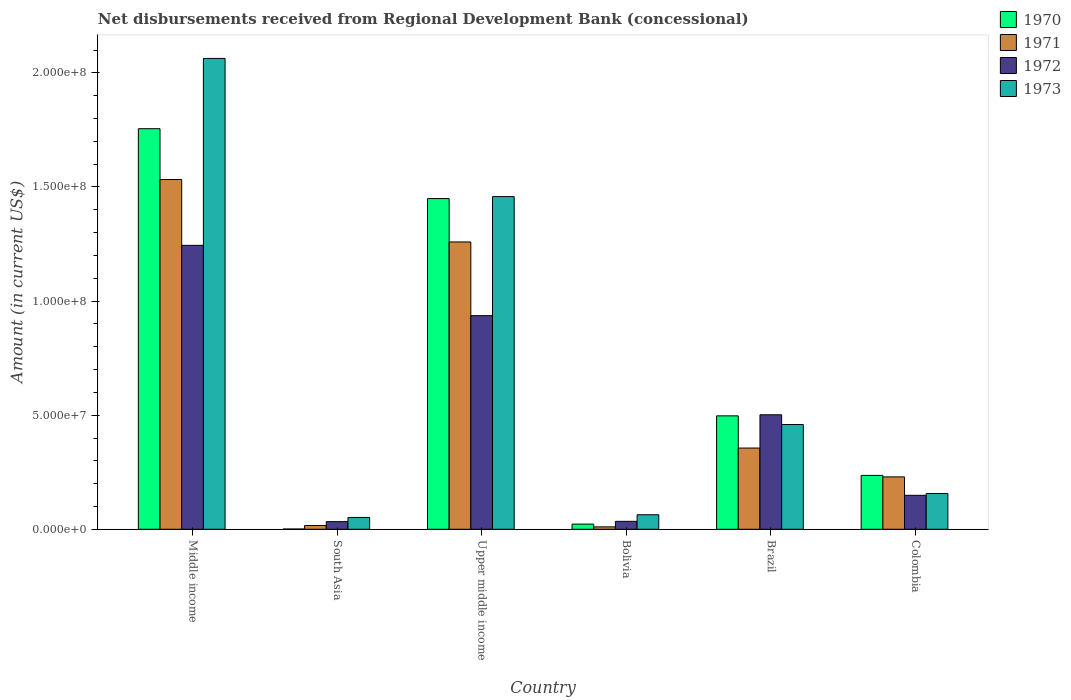How many different coloured bars are there?
Your response must be concise. 4. How many groups of bars are there?
Your response must be concise. 6. What is the label of the 2nd group of bars from the left?
Offer a terse response. South Asia. In how many cases, is the number of bars for a given country not equal to the number of legend labels?
Give a very brief answer. 0. What is the amount of disbursements received from Regional Development Bank in 1971 in Middle income?
Provide a succinct answer. 1.53e+08. Across all countries, what is the maximum amount of disbursements received from Regional Development Bank in 1971?
Offer a terse response. 1.53e+08. Across all countries, what is the minimum amount of disbursements received from Regional Development Bank in 1973?
Provide a short and direct response. 5.18e+06. In which country was the amount of disbursements received from Regional Development Bank in 1973 maximum?
Make the answer very short. Middle income. In which country was the amount of disbursements received from Regional Development Bank in 1972 minimum?
Offer a very short reply. South Asia. What is the total amount of disbursements received from Regional Development Bank in 1971 in the graph?
Your answer should be very brief. 3.40e+08. What is the difference between the amount of disbursements received from Regional Development Bank in 1970 in Bolivia and that in Colombia?
Provide a short and direct response. -2.13e+07. What is the difference between the amount of disbursements received from Regional Development Bank in 1971 in Upper middle income and the amount of disbursements received from Regional Development Bank in 1972 in Brazil?
Keep it short and to the point. 7.57e+07. What is the average amount of disbursements received from Regional Development Bank in 1972 per country?
Keep it short and to the point. 4.83e+07. What is the difference between the amount of disbursements received from Regional Development Bank of/in 1972 and amount of disbursements received from Regional Development Bank of/in 1970 in Upper middle income?
Ensure brevity in your answer.  -5.13e+07. What is the ratio of the amount of disbursements received from Regional Development Bank in 1971 in Bolivia to that in Upper middle income?
Give a very brief answer. 0.01. Is the difference between the amount of disbursements received from Regional Development Bank in 1972 in Bolivia and Middle income greater than the difference between the amount of disbursements received from Regional Development Bank in 1970 in Bolivia and Middle income?
Your answer should be compact. Yes. What is the difference between the highest and the second highest amount of disbursements received from Regional Development Bank in 1973?
Your answer should be very brief. 1.60e+08. What is the difference between the highest and the lowest amount of disbursements received from Regional Development Bank in 1973?
Provide a succinct answer. 2.01e+08. In how many countries, is the amount of disbursements received from Regional Development Bank in 1972 greater than the average amount of disbursements received from Regional Development Bank in 1972 taken over all countries?
Provide a succinct answer. 3. Is the sum of the amount of disbursements received from Regional Development Bank in 1971 in Bolivia and South Asia greater than the maximum amount of disbursements received from Regional Development Bank in 1972 across all countries?
Your response must be concise. No. Is it the case that in every country, the sum of the amount of disbursements received from Regional Development Bank in 1972 and amount of disbursements received from Regional Development Bank in 1970 is greater than the sum of amount of disbursements received from Regional Development Bank in 1973 and amount of disbursements received from Regional Development Bank in 1971?
Your answer should be very brief. No. Is it the case that in every country, the sum of the amount of disbursements received from Regional Development Bank in 1971 and amount of disbursements received from Regional Development Bank in 1972 is greater than the amount of disbursements received from Regional Development Bank in 1973?
Make the answer very short. No. Does the graph contain any zero values?
Keep it short and to the point. No. Where does the legend appear in the graph?
Keep it short and to the point. Top right. How many legend labels are there?
Give a very brief answer. 4. What is the title of the graph?
Offer a very short reply. Net disbursements received from Regional Development Bank (concessional). What is the Amount (in current US$) in 1970 in Middle income?
Make the answer very short. 1.76e+08. What is the Amount (in current US$) in 1971 in Middle income?
Your answer should be compact. 1.53e+08. What is the Amount (in current US$) in 1972 in Middle income?
Give a very brief answer. 1.24e+08. What is the Amount (in current US$) of 1973 in Middle income?
Your answer should be very brief. 2.06e+08. What is the Amount (in current US$) in 1970 in South Asia?
Keep it short and to the point. 1.09e+05. What is the Amount (in current US$) of 1971 in South Asia?
Offer a terse response. 1.65e+06. What is the Amount (in current US$) in 1972 in South Asia?
Make the answer very short. 3.35e+06. What is the Amount (in current US$) in 1973 in South Asia?
Your answer should be compact. 5.18e+06. What is the Amount (in current US$) of 1970 in Upper middle income?
Your answer should be compact. 1.45e+08. What is the Amount (in current US$) in 1971 in Upper middle income?
Offer a very short reply. 1.26e+08. What is the Amount (in current US$) of 1972 in Upper middle income?
Your answer should be compact. 9.36e+07. What is the Amount (in current US$) of 1973 in Upper middle income?
Ensure brevity in your answer.  1.46e+08. What is the Amount (in current US$) in 1970 in Bolivia?
Keep it short and to the point. 2.27e+06. What is the Amount (in current US$) of 1971 in Bolivia?
Your response must be concise. 1.06e+06. What is the Amount (in current US$) of 1972 in Bolivia?
Offer a terse response. 3.48e+06. What is the Amount (in current US$) in 1973 in Bolivia?
Your response must be concise. 6.36e+06. What is the Amount (in current US$) of 1970 in Brazil?
Make the answer very short. 4.97e+07. What is the Amount (in current US$) of 1971 in Brazil?
Provide a succinct answer. 3.56e+07. What is the Amount (in current US$) of 1972 in Brazil?
Ensure brevity in your answer.  5.02e+07. What is the Amount (in current US$) in 1973 in Brazil?
Provide a succinct answer. 4.59e+07. What is the Amount (in current US$) in 1970 in Colombia?
Your answer should be compact. 2.36e+07. What is the Amount (in current US$) in 1971 in Colombia?
Your answer should be very brief. 2.30e+07. What is the Amount (in current US$) in 1972 in Colombia?
Provide a short and direct response. 1.49e+07. What is the Amount (in current US$) in 1973 in Colombia?
Provide a succinct answer. 1.57e+07. Across all countries, what is the maximum Amount (in current US$) of 1970?
Provide a short and direct response. 1.76e+08. Across all countries, what is the maximum Amount (in current US$) of 1971?
Your answer should be compact. 1.53e+08. Across all countries, what is the maximum Amount (in current US$) in 1972?
Your answer should be very brief. 1.24e+08. Across all countries, what is the maximum Amount (in current US$) of 1973?
Provide a short and direct response. 2.06e+08. Across all countries, what is the minimum Amount (in current US$) of 1970?
Provide a short and direct response. 1.09e+05. Across all countries, what is the minimum Amount (in current US$) in 1971?
Ensure brevity in your answer.  1.06e+06. Across all countries, what is the minimum Amount (in current US$) in 1972?
Keep it short and to the point. 3.35e+06. Across all countries, what is the minimum Amount (in current US$) of 1973?
Offer a terse response. 5.18e+06. What is the total Amount (in current US$) of 1970 in the graph?
Keep it short and to the point. 3.96e+08. What is the total Amount (in current US$) in 1971 in the graph?
Offer a terse response. 3.40e+08. What is the total Amount (in current US$) of 1972 in the graph?
Offer a very short reply. 2.90e+08. What is the total Amount (in current US$) in 1973 in the graph?
Your response must be concise. 4.25e+08. What is the difference between the Amount (in current US$) in 1970 in Middle income and that in South Asia?
Your answer should be compact. 1.75e+08. What is the difference between the Amount (in current US$) in 1971 in Middle income and that in South Asia?
Offer a very short reply. 1.52e+08. What is the difference between the Amount (in current US$) of 1972 in Middle income and that in South Asia?
Keep it short and to the point. 1.21e+08. What is the difference between the Amount (in current US$) in 1973 in Middle income and that in South Asia?
Offer a terse response. 2.01e+08. What is the difference between the Amount (in current US$) in 1970 in Middle income and that in Upper middle income?
Provide a short and direct response. 3.06e+07. What is the difference between the Amount (in current US$) of 1971 in Middle income and that in Upper middle income?
Your response must be concise. 2.74e+07. What is the difference between the Amount (in current US$) in 1972 in Middle income and that in Upper middle income?
Keep it short and to the point. 3.08e+07. What is the difference between the Amount (in current US$) of 1973 in Middle income and that in Upper middle income?
Provide a short and direct response. 6.06e+07. What is the difference between the Amount (in current US$) of 1970 in Middle income and that in Bolivia?
Offer a terse response. 1.73e+08. What is the difference between the Amount (in current US$) in 1971 in Middle income and that in Bolivia?
Provide a succinct answer. 1.52e+08. What is the difference between the Amount (in current US$) of 1972 in Middle income and that in Bolivia?
Make the answer very short. 1.21e+08. What is the difference between the Amount (in current US$) of 1973 in Middle income and that in Bolivia?
Your response must be concise. 2.00e+08. What is the difference between the Amount (in current US$) in 1970 in Middle income and that in Brazil?
Provide a succinct answer. 1.26e+08. What is the difference between the Amount (in current US$) in 1971 in Middle income and that in Brazil?
Your answer should be very brief. 1.18e+08. What is the difference between the Amount (in current US$) of 1972 in Middle income and that in Brazil?
Provide a short and direct response. 7.43e+07. What is the difference between the Amount (in current US$) in 1973 in Middle income and that in Brazil?
Your response must be concise. 1.60e+08. What is the difference between the Amount (in current US$) of 1970 in Middle income and that in Colombia?
Make the answer very short. 1.52e+08. What is the difference between the Amount (in current US$) in 1971 in Middle income and that in Colombia?
Offer a very short reply. 1.30e+08. What is the difference between the Amount (in current US$) of 1972 in Middle income and that in Colombia?
Your answer should be very brief. 1.10e+08. What is the difference between the Amount (in current US$) in 1973 in Middle income and that in Colombia?
Your answer should be compact. 1.91e+08. What is the difference between the Amount (in current US$) in 1970 in South Asia and that in Upper middle income?
Your response must be concise. -1.45e+08. What is the difference between the Amount (in current US$) in 1971 in South Asia and that in Upper middle income?
Keep it short and to the point. -1.24e+08. What is the difference between the Amount (in current US$) in 1972 in South Asia and that in Upper middle income?
Provide a succinct answer. -9.03e+07. What is the difference between the Amount (in current US$) of 1973 in South Asia and that in Upper middle income?
Give a very brief answer. -1.41e+08. What is the difference between the Amount (in current US$) in 1970 in South Asia and that in Bolivia?
Ensure brevity in your answer.  -2.16e+06. What is the difference between the Amount (in current US$) of 1971 in South Asia and that in Bolivia?
Ensure brevity in your answer.  5.92e+05. What is the difference between the Amount (in current US$) in 1972 in South Asia and that in Bolivia?
Provide a succinct answer. -1.30e+05. What is the difference between the Amount (in current US$) in 1973 in South Asia and that in Bolivia?
Keep it short and to the point. -1.18e+06. What is the difference between the Amount (in current US$) of 1970 in South Asia and that in Brazil?
Offer a very short reply. -4.96e+07. What is the difference between the Amount (in current US$) in 1971 in South Asia and that in Brazil?
Give a very brief answer. -3.39e+07. What is the difference between the Amount (in current US$) of 1972 in South Asia and that in Brazil?
Offer a terse response. -4.68e+07. What is the difference between the Amount (in current US$) in 1973 in South Asia and that in Brazil?
Keep it short and to the point. -4.07e+07. What is the difference between the Amount (in current US$) in 1970 in South Asia and that in Colombia?
Your answer should be compact. -2.35e+07. What is the difference between the Amount (in current US$) of 1971 in South Asia and that in Colombia?
Offer a very short reply. -2.13e+07. What is the difference between the Amount (in current US$) in 1972 in South Asia and that in Colombia?
Give a very brief answer. -1.15e+07. What is the difference between the Amount (in current US$) of 1973 in South Asia and that in Colombia?
Provide a succinct answer. -1.05e+07. What is the difference between the Amount (in current US$) in 1970 in Upper middle income and that in Bolivia?
Offer a terse response. 1.43e+08. What is the difference between the Amount (in current US$) of 1971 in Upper middle income and that in Bolivia?
Provide a short and direct response. 1.25e+08. What is the difference between the Amount (in current US$) in 1972 in Upper middle income and that in Bolivia?
Provide a short and direct response. 9.01e+07. What is the difference between the Amount (in current US$) in 1973 in Upper middle income and that in Bolivia?
Your answer should be very brief. 1.39e+08. What is the difference between the Amount (in current US$) in 1970 in Upper middle income and that in Brazil?
Provide a succinct answer. 9.52e+07. What is the difference between the Amount (in current US$) of 1971 in Upper middle income and that in Brazil?
Your answer should be very brief. 9.03e+07. What is the difference between the Amount (in current US$) in 1972 in Upper middle income and that in Brazil?
Ensure brevity in your answer.  4.34e+07. What is the difference between the Amount (in current US$) of 1973 in Upper middle income and that in Brazil?
Make the answer very short. 9.99e+07. What is the difference between the Amount (in current US$) of 1970 in Upper middle income and that in Colombia?
Your response must be concise. 1.21e+08. What is the difference between the Amount (in current US$) of 1971 in Upper middle income and that in Colombia?
Your answer should be very brief. 1.03e+08. What is the difference between the Amount (in current US$) of 1972 in Upper middle income and that in Colombia?
Your answer should be compact. 7.87e+07. What is the difference between the Amount (in current US$) of 1973 in Upper middle income and that in Colombia?
Make the answer very short. 1.30e+08. What is the difference between the Amount (in current US$) of 1970 in Bolivia and that in Brazil?
Offer a terse response. -4.74e+07. What is the difference between the Amount (in current US$) in 1971 in Bolivia and that in Brazil?
Your answer should be very brief. -3.45e+07. What is the difference between the Amount (in current US$) in 1972 in Bolivia and that in Brazil?
Your response must be concise. -4.67e+07. What is the difference between the Amount (in current US$) in 1973 in Bolivia and that in Brazil?
Your answer should be compact. -3.95e+07. What is the difference between the Amount (in current US$) in 1970 in Bolivia and that in Colombia?
Offer a very short reply. -2.13e+07. What is the difference between the Amount (in current US$) in 1971 in Bolivia and that in Colombia?
Provide a short and direct response. -2.19e+07. What is the difference between the Amount (in current US$) of 1972 in Bolivia and that in Colombia?
Make the answer very short. -1.14e+07. What is the difference between the Amount (in current US$) of 1973 in Bolivia and that in Colombia?
Give a very brief answer. -9.33e+06. What is the difference between the Amount (in current US$) in 1970 in Brazil and that in Colombia?
Make the answer very short. 2.61e+07. What is the difference between the Amount (in current US$) of 1971 in Brazil and that in Colombia?
Keep it short and to the point. 1.26e+07. What is the difference between the Amount (in current US$) of 1972 in Brazil and that in Colombia?
Your response must be concise. 3.53e+07. What is the difference between the Amount (in current US$) of 1973 in Brazil and that in Colombia?
Offer a terse response. 3.02e+07. What is the difference between the Amount (in current US$) of 1970 in Middle income and the Amount (in current US$) of 1971 in South Asia?
Provide a short and direct response. 1.74e+08. What is the difference between the Amount (in current US$) in 1970 in Middle income and the Amount (in current US$) in 1972 in South Asia?
Your answer should be compact. 1.72e+08. What is the difference between the Amount (in current US$) in 1970 in Middle income and the Amount (in current US$) in 1973 in South Asia?
Provide a short and direct response. 1.70e+08. What is the difference between the Amount (in current US$) in 1971 in Middle income and the Amount (in current US$) in 1972 in South Asia?
Provide a succinct answer. 1.50e+08. What is the difference between the Amount (in current US$) in 1971 in Middle income and the Amount (in current US$) in 1973 in South Asia?
Make the answer very short. 1.48e+08. What is the difference between the Amount (in current US$) of 1972 in Middle income and the Amount (in current US$) of 1973 in South Asia?
Provide a short and direct response. 1.19e+08. What is the difference between the Amount (in current US$) of 1970 in Middle income and the Amount (in current US$) of 1971 in Upper middle income?
Make the answer very short. 4.96e+07. What is the difference between the Amount (in current US$) in 1970 in Middle income and the Amount (in current US$) in 1972 in Upper middle income?
Offer a terse response. 8.19e+07. What is the difference between the Amount (in current US$) in 1970 in Middle income and the Amount (in current US$) in 1973 in Upper middle income?
Provide a succinct answer. 2.98e+07. What is the difference between the Amount (in current US$) in 1971 in Middle income and the Amount (in current US$) in 1972 in Upper middle income?
Your answer should be compact. 5.97e+07. What is the difference between the Amount (in current US$) of 1971 in Middle income and the Amount (in current US$) of 1973 in Upper middle income?
Your answer should be very brief. 7.49e+06. What is the difference between the Amount (in current US$) in 1972 in Middle income and the Amount (in current US$) in 1973 in Upper middle income?
Your response must be concise. -2.14e+07. What is the difference between the Amount (in current US$) of 1970 in Middle income and the Amount (in current US$) of 1971 in Bolivia?
Offer a very short reply. 1.74e+08. What is the difference between the Amount (in current US$) of 1970 in Middle income and the Amount (in current US$) of 1972 in Bolivia?
Your answer should be compact. 1.72e+08. What is the difference between the Amount (in current US$) in 1970 in Middle income and the Amount (in current US$) in 1973 in Bolivia?
Your response must be concise. 1.69e+08. What is the difference between the Amount (in current US$) of 1971 in Middle income and the Amount (in current US$) of 1972 in Bolivia?
Give a very brief answer. 1.50e+08. What is the difference between the Amount (in current US$) in 1971 in Middle income and the Amount (in current US$) in 1973 in Bolivia?
Offer a very short reply. 1.47e+08. What is the difference between the Amount (in current US$) in 1972 in Middle income and the Amount (in current US$) in 1973 in Bolivia?
Provide a succinct answer. 1.18e+08. What is the difference between the Amount (in current US$) of 1970 in Middle income and the Amount (in current US$) of 1971 in Brazil?
Your answer should be very brief. 1.40e+08. What is the difference between the Amount (in current US$) of 1970 in Middle income and the Amount (in current US$) of 1972 in Brazil?
Provide a succinct answer. 1.25e+08. What is the difference between the Amount (in current US$) of 1970 in Middle income and the Amount (in current US$) of 1973 in Brazil?
Your answer should be compact. 1.30e+08. What is the difference between the Amount (in current US$) in 1971 in Middle income and the Amount (in current US$) in 1972 in Brazil?
Provide a succinct answer. 1.03e+08. What is the difference between the Amount (in current US$) in 1971 in Middle income and the Amount (in current US$) in 1973 in Brazil?
Give a very brief answer. 1.07e+08. What is the difference between the Amount (in current US$) of 1972 in Middle income and the Amount (in current US$) of 1973 in Brazil?
Ensure brevity in your answer.  7.85e+07. What is the difference between the Amount (in current US$) in 1970 in Middle income and the Amount (in current US$) in 1971 in Colombia?
Your response must be concise. 1.53e+08. What is the difference between the Amount (in current US$) of 1970 in Middle income and the Amount (in current US$) of 1972 in Colombia?
Your response must be concise. 1.61e+08. What is the difference between the Amount (in current US$) of 1970 in Middle income and the Amount (in current US$) of 1973 in Colombia?
Offer a very short reply. 1.60e+08. What is the difference between the Amount (in current US$) in 1971 in Middle income and the Amount (in current US$) in 1972 in Colombia?
Provide a succinct answer. 1.38e+08. What is the difference between the Amount (in current US$) in 1971 in Middle income and the Amount (in current US$) in 1973 in Colombia?
Provide a short and direct response. 1.38e+08. What is the difference between the Amount (in current US$) of 1972 in Middle income and the Amount (in current US$) of 1973 in Colombia?
Provide a succinct answer. 1.09e+08. What is the difference between the Amount (in current US$) in 1970 in South Asia and the Amount (in current US$) in 1971 in Upper middle income?
Your response must be concise. -1.26e+08. What is the difference between the Amount (in current US$) of 1970 in South Asia and the Amount (in current US$) of 1972 in Upper middle income?
Ensure brevity in your answer.  -9.35e+07. What is the difference between the Amount (in current US$) in 1970 in South Asia and the Amount (in current US$) in 1973 in Upper middle income?
Give a very brief answer. -1.46e+08. What is the difference between the Amount (in current US$) in 1971 in South Asia and the Amount (in current US$) in 1972 in Upper middle income?
Offer a terse response. -9.20e+07. What is the difference between the Amount (in current US$) of 1971 in South Asia and the Amount (in current US$) of 1973 in Upper middle income?
Give a very brief answer. -1.44e+08. What is the difference between the Amount (in current US$) of 1972 in South Asia and the Amount (in current US$) of 1973 in Upper middle income?
Offer a very short reply. -1.42e+08. What is the difference between the Amount (in current US$) in 1970 in South Asia and the Amount (in current US$) in 1971 in Bolivia?
Give a very brief answer. -9.49e+05. What is the difference between the Amount (in current US$) in 1970 in South Asia and the Amount (in current US$) in 1972 in Bolivia?
Ensure brevity in your answer.  -3.37e+06. What is the difference between the Amount (in current US$) in 1970 in South Asia and the Amount (in current US$) in 1973 in Bolivia?
Your response must be concise. -6.25e+06. What is the difference between the Amount (in current US$) of 1971 in South Asia and the Amount (in current US$) of 1972 in Bolivia?
Keep it short and to the point. -1.83e+06. What is the difference between the Amount (in current US$) of 1971 in South Asia and the Amount (in current US$) of 1973 in Bolivia?
Provide a succinct answer. -4.71e+06. What is the difference between the Amount (in current US$) of 1972 in South Asia and the Amount (in current US$) of 1973 in Bolivia?
Provide a succinct answer. -3.01e+06. What is the difference between the Amount (in current US$) of 1970 in South Asia and the Amount (in current US$) of 1971 in Brazil?
Make the answer very short. -3.55e+07. What is the difference between the Amount (in current US$) in 1970 in South Asia and the Amount (in current US$) in 1972 in Brazil?
Keep it short and to the point. -5.01e+07. What is the difference between the Amount (in current US$) in 1970 in South Asia and the Amount (in current US$) in 1973 in Brazil?
Ensure brevity in your answer.  -4.58e+07. What is the difference between the Amount (in current US$) of 1971 in South Asia and the Amount (in current US$) of 1972 in Brazil?
Make the answer very short. -4.85e+07. What is the difference between the Amount (in current US$) in 1971 in South Asia and the Amount (in current US$) in 1973 in Brazil?
Ensure brevity in your answer.  -4.43e+07. What is the difference between the Amount (in current US$) in 1972 in South Asia and the Amount (in current US$) in 1973 in Brazil?
Offer a terse response. -4.26e+07. What is the difference between the Amount (in current US$) of 1970 in South Asia and the Amount (in current US$) of 1971 in Colombia?
Offer a terse response. -2.29e+07. What is the difference between the Amount (in current US$) in 1970 in South Asia and the Amount (in current US$) in 1972 in Colombia?
Your answer should be very brief. -1.48e+07. What is the difference between the Amount (in current US$) of 1970 in South Asia and the Amount (in current US$) of 1973 in Colombia?
Ensure brevity in your answer.  -1.56e+07. What is the difference between the Amount (in current US$) in 1971 in South Asia and the Amount (in current US$) in 1972 in Colombia?
Your answer should be compact. -1.32e+07. What is the difference between the Amount (in current US$) of 1971 in South Asia and the Amount (in current US$) of 1973 in Colombia?
Provide a succinct answer. -1.40e+07. What is the difference between the Amount (in current US$) in 1972 in South Asia and the Amount (in current US$) in 1973 in Colombia?
Offer a terse response. -1.23e+07. What is the difference between the Amount (in current US$) of 1970 in Upper middle income and the Amount (in current US$) of 1971 in Bolivia?
Your answer should be compact. 1.44e+08. What is the difference between the Amount (in current US$) in 1970 in Upper middle income and the Amount (in current US$) in 1972 in Bolivia?
Your answer should be very brief. 1.41e+08. What is the difference between the Amount (in current US$) in 1970 in Upper middle income and the Amount (in current US$) in 1973 in Bolivia?
Make the answer very short. 1.39e+08. What is the difference between the Amount (in current US$) in 1971 in Upper middle income and the Amount (in current US$) in 1972 in Bolivia?
Provide a succinct answer. 1.22e+08. What is the difference between the Amount (in current US$) in 1971 in Upper middle income and the Amount (in current US$) in 1973 in Bolivia?
Keep it short and to the point. 1.20e+08. What is the difference between the Amount (in current US$) in 1972 in Upper middle income and the Amount (in current US$) in 1973 in Bolivia?
Offer a terse response. 8.72e+07. What is the difference between the Amount (in current US$) in 1970 in Upper middle income and the Amount (in current US$) in 1971 in Brazil?
Provide a short and direct response. 1.09e+08. What is the difference between the Amount (in current US$) of 1970 in Upper middle income and the Amount (in current US$) of 1972 in Brazil?
Give a very brief answer. 9.48e+07. What is the difference between the Amount (in current US$) in 1970 in Upper middle income and the Amount (in current US$) in 1973 in Brazil?
Provide a short and direct response. 9.90e+07. What is the difference between the Amount (in current US$) in 1971 in Upper middle income and the Amount (in current US$) in 1972 in Brazil?
Your answer should be compact. 7.57e+07. What is the difference between the Amount (in current US$) of 1971 in Upper middle income and the Amount (in current US$) of 1973 in Brazil?
Ensure brevity in your answer.  8.00e+07. What is the difference between the Amount (in current US$) in 1972 in Upper middle income and the Amount (in current US$) in 1973 in Brazil?
Make the answer very short. 4.77e+07. What is the difference between the Amount (in current US$) of 1970 in Upper middle income and the Amount (in current US$) of 1971 in Colombia?
Offer a terse response. 1.22e+08. What is the difference between the Amount (in current US$) of 1970 in Upper middle income and the Amount (in current US$) of 1972 in Colombia?
Make the answer very short. 1.30e+08. What is the difference between the Amount (in current US$) in 1970 in Upper middle income and the Amount (in current US$) in 1973 in Colombia?
Your response must be concise. 1.29e+08. What is the difference between the Amount (in current US$) of 1971 in Upper middle income and the Amount (in current US$) of 1972 in Colombia?
Your answer should be very brief. 1.11e+08. What is the difference between the Amount (in current US$) of 1971 in Upper middle income and the Amount (in current US$) of 1973 in Colombia?
Provide a short and direct response. 1.10e+08. What is the difference between the Amount (in current US$) of 1972 in Upper middle income and the Amount (in current US$) of 1973 in Colombia?
Provide a short and direct response. 7.79e+07. What is the difference between the Amount (in current US$) in 1970 in Bolivia and the Amount (in current US$) in 1971 in Brazil?
Provide a succinct answer. -3.33e+07. What is the difference between the Amount (in current US$) of 1970 in Bolivia and the Amount (in current US$) of 1972 in Brazil?
Your response must be concise. -4.79e+07. What is the difference between the Amount (in current US$) of 1970 in Bolivia and the Amount (in current US$) of 1973 in Brazil?
Your response must be concise. -4.36e+07. What is the difference between the Amount (in current US$) in 1971 in Bolivia and the Amount (in current US$) in 1972 in Brazil?
Make the answer very short. -4.91e+07. What is the difference between the Amount (in current US$) of 1971 in Bolivia and the Amount (in current US$) of 1973 in Brazil?
Offer a very short reply. -4.49e+07. What is the difference between the Amount (in current US$) in 1972 in Bolivia and the Amount (in current US$) in 1973 in Brazil?
Offer a terse response. -4.24e+07. What is the difference between the Amount (in current US$) in 1970 in Bolivia and the Amount (in current US$) in 1971 in Colombia?
Your response must be concise. -2.07e+07. What is the difference between the Amount (in current US$) in 1970 in Bolivia and the Amount (in current US$) in 1972 in Colombia?
Your answer should be very brief. -1.26e+07. What is the difference between the Amount (in current US$) in 1970 in Bolivia and the Amount (in current US$) in 1973 in Colombia?
Provide a short and direct response. -1.34e+07. What is the difference between the Amount (in current US$) in 1971 in Bolivia and the Amount (in current US$) in 1972 in Colombia?
Your response must be concise. -1.38e+07. What is the difference between the Amount (in current US$) of 1971 in Bolivia and the Amount (in current US$) of 1973 in Colombia?
Keep it short and to the point. -1.46e+07. What is the difference between the Amount (in current US$) in 1972 in Bolivia and the Amount (in current US$) in 1973 in Colombia?
Provide a short and direct response. -1.22e+07. What is the difference between the Amount (in current US$) of 1970 in Brazil and the Amount (in current US$) of 1971 in Colombia?
Give a very brief answer. 2.67e+07. What is the difference between the Amount (in current US$) of 1970 in Brazil and the Amount (in current US$) of 1972 in Colombia?
Give a very brief answer. 3.48e+07. What is the difference between the Amount (in current US$) of 1970 in Brazil and the Amount (in current US$) of 1973 in Colombia?
Offer a very short reply. 3.40e+07. What is the difference between the Amount (in current US$) of 1971 in Brazil and the Amount (in current US$) of 1972 in Colombia?
Offer a terse response. 2.07e+07. What is the difference between the Amount (in current US$) in 1971 in Brazil and the Amount (in current US$) in 1973 in Colombia?
Your answer should be very brief. 1.99e+07. What is the difference between the Amount (in current US$) in 1972 in Brazil and the Amount (in current US$) in 1973 in Colombia?
Your answer should be compact. 3.45e+07. What is the average Amount (in current US$) in 1970 per country?
Make the answer very short. 6.60e+07. What is the average Amount (in current US$) of 1971 per country?
Make the answer very short. 5.67e+07. What is the average Amount (in current US$) of 1972 per country?
Provide a succinct answer. 4.83e+07. What is the average Amount (in current US$) of 1973 per country?
Keep it short and to the point. 7.09e+07. What is the difference between the Amount (in current US$) in 1970 and Amount (in current US$) in 1971 in Middle income?
Make the answer very short. 2.23e+07. What is the difference between the Amount (in current US$) in 1970 and Amount (in current US$) in 1972 in Middle income?
Your response must be concise. 5.11e+07. What is the difference between the Amount (in current US$) in 1970 and Amount (in current US$) in 1973 in Middle income?
Make the answer very short. -3.08e+07. What is the difference between the Amount (in current US$) in 1971 and Amount (in current US$) in 1972 in Middle income?
Offer a very short reply. 2.88e+07. What is the difference between the Amount (in current US$) of 1971 and Amount (in current US$) of 1973 in Middle income?
Your response must be concise. -5.31e+07. What is the difference between the Amount (in current US$) of 1972 and Amount (in current US$) of 1973 in Middle income?
Provide a succinct answer. -8.19e+07. What is the difference between the Amount (in current US$) in 1970 and Amount (in current US$) in 1971 in South Asia?
Your answer should be very brief. -1.54e+06. What is the difference between the Amount (in current US$) of 1970 and Amount (in current US$) of 1972 in South Asia?
Provide a succinct answer. -3.24e+06. What is the difference between the Amount (in current US$) of 1970 and Amount (in current US$) of 1973 in South Asia?
Give a very brief answer. -5.08e+06. What is the difference between the Amount (in current US$) in 1971 and Amount (in current US$) in 1972 in South Asia?
Ensure brevity in your answer.  -1.70e+06. What is the difference between the Amount (in current US$) in 1971 and Amount (in current US$) in 1973 in South Asia?
Keep it short and to the point. -3.53e+06. What is the difference between the Amount (in current US$) in 1972 and Amount (in current US$) in 1973 in South Asia?
Ensure brevity in your answer.  -1.83e+06. What is the difference between the Amount (in current US$) in 1970 and Amount (in current US$) in 1971 in Upper middle income?
Your response must be concise. 1.90e+07. What is the difference between the Amount (in current US$) of 1970 and Amount (in current US$) of 1972 in Upper middle income?
Keep it short and to the point. 5.13e+07. What is the difference between the Amount (in current US$) of 1970 and Amount (in current US$) of 1973 in Upper middle income?
Your answer should be compact. -8.58e+05. What is the difference between the Amount (in current US$) in 1971 and Amount (in current US$) in 1972 in Upper middle income?
Your response must be concise. 3.23e+07. What is the difference between the Amount (in current US$) of 1971 and Amount (in current US$) of 1973 in Upper middle income?
Your response must be concise. -1.99e+07. What is the difference between the Amount (in current US$) of 1972 and Amount (in current US$) of 1973 in Upper middle income?
Your answer should be very brief. -5.22e+07. What is the difference between the Amount (in current US$) in 1970 and Amount (in current US$) in 1971 in Bolivia?
Offer a very short reply. 1.21e+06. What is the difference between the Amount (in current US$) in 1970 and Amount (in current US$) in 1972 in Bolivia?
Provide a short and direct response. -1.21e+06. What is the difference between the Amount (in current US$) in 1970 and Amount (in current US$) in 1973 in Bolivia?
Offer a very short reply. -4.09e+06. What is the difference between the Amount (in current US$) of 1971 and Amount (in current US$) of 1972 in Bolivia?
Offer a terse response. -2.42e+06. What is the difference between the Amount (in current US$) of 1971 and Amount (in current US$) of 1973 in Bolivia?
Keep it short and to the point. -5.30e+06. What is the difference between the Amount (in current US$) in 1972 and Amount (in current US$) in 1973 in Bolivia?
Your response must be concise. -2.88e+06. What is the difference between the Amount (in current US$) of 1970 and Amount (in current US$) of 1971 in Brazil?
Make the answer very short. 1.41e+07. What is the difference between the Amount (in current US$) in 1970 and Amount (in current US$) in 1972 in Brazil?
Your answer should be very brief. -4.68e+05. What is the difference between the Amount (in current US$) of 1970 and Amount (in current US$) of 1973 in Brazil?
Your response must be concise. 3.80e+06. What is the difference between the Amount (in current US$) of 1971 and Amount (in current US$) of 1972 in Brazil?
Make the answer very short. -1.46e+07. What is the difference between the Amount (in current US$) of 1971 and Amount (in current US$) of 1973 in Brazil?
Offer a terse response. -1.03e+07. What is the difference between the Amount (in current US$) in 1972 and Amount (in current US$) in 1973 in Brazil?
Give a very brief answer. 4.27e+06. What is the difference between the Amount (in current US$) in 1970 and Amount (in current US$) in 1971 in Colombia?
Make the answer very short. 6.52e+05. What is the difference between the Amount (in current US$) of 1970 and Amount (in current US$) of 1972 in Colombia?
Offer a terse response. 8.74e+06. What is the difference between the Amount (in current US$) in 1970 and Amount (in current US$) in 1973 in Colombia?
Your answer should be compact. 7.93e+06. What is the difference between the Amount (in current US$) of 1971 and Amount (in current US$) of 1972 in Colombia?
Provide a succinct answer. 8.08e+06. What is the difference between the Amount (in current US$) in 1971 and Amount (in current US$) in 1973 in Colombia?
Provide a short and direct response. 7.28e+06. What is the difference between the Amount (in current US$) of 1972 and Amount (in current US$) of 1973 in Colombia?
Provide a succinct answer. -8.09e+05. What is the ratio of the Amount (in current US$) of 1970 in Middle income to that in South Asia?
Your answer should be compact. 1610.58. What is the ratio of the Amount (in current US$) in 1971 in Middle income to that in South Asia?
Your response must be concise. 92.89. What is the ratio of the Amount (in current US$) of 1972 in Middle income to that in South Asia?
Ensure brevity in your answer.  37.14. What is the ratio of the Amount (in current US$) of 1973 in Middle income to that in South Asia?
Ensure brevity in your answer.  39.8. What is the ratio of the Amount (in current US$) in 1970 in Middle income to that in Upper middle income?
Your answer should be very brief. 1.21. What is the ratio of the Amount (in current US$) of 1971 in Middle income to that in Upper middle income?
Your answer should be very brief. 1.22. What is the ratio of the Amount (in current US$) of 1972 in Middle income to that in Upper middle income?
Offer a very short reply. 1.33. What is the ratio of the Amount (in current US$) in 1973 in Middle income to that in Upper middle income?
Your answer should be compact. 1.42. What is the ratio of the Amount (in current US$) in 1970 in Middle income to that in Bolivia?
Give a very brief answer. 77.34. What is the ratio of the Amount (in current US$) of 1971 in Middle income to that in Bolivia?
Your answer should be compact. 144.87. What is the ratio of the Amount (in current US$) of 1972 in Middle income to that in Bolivia?
Provide a short and direct response. 35.76. What is the ratio of the Amount (in current US$) of 1973 in Middle income to that in Bolivia?
Your response must be concise. 32.44. What is the ratio of the Amount (in current US$) in 1970 in Middle income to that in Brazil?
Provide a short and direct response. 3.53. What is the ratio of the Amount (in current US$) of 1971 in Middle income to that in Brazil?
Offer a terse response. 4.31. What is the ratio of the Amount (in current US$) in 1972 in Middle income to that in Brazil?
Keep it short and to the point. 2.48. What is the ratio of the Amount (in current US$) in 1973 in Middle income to that in Brazil?
Your response must be concise. 4.49. What is the ratio of the Amount (in current US$) of 1970 in Middle income to that in Colombia?
Your answer should be compact. 7.43. What is the ratio of the Amount (in current US$) of 1971 in Middle income to that in Colombia?
Keep it short and to the point. 6.67. What is the ratio of the Amount (in current US$) of 1972 in Middle income to that in Colombia?
Make the answer very short. 8.36. What is the ratio of the Amount (in current US$) in 1973 in Middle income to that in Colombia?
Keep it short and to the point. 13.15. What is the ratio of the Amount (in current US$) of 1970 in South Asia to that in Upper middle income?
Your answer should be very brief. 0. What is the ratio of the Amount (in current US$) of 1971 in South Asia to that in Upper middle income?
Provide a short and direct response. 0.01. What is the ratio of the Amount (in current US$) in 1972 in South Asia to that in Upper middle income?
Offer a very short reply. 0.04. What is the ratio of the Amount (in current US$) in 1973 in South Asia to that in Upper middle income?
Offer a very short reply. 0.04. What is the ratio of the Amount (in current US$) of 1970 in South Asia to that in Bolivia?
Your response must be concise. 0.05. What is the ratio of the Amount (in current US$) of 1971 in South Asia to that in Bolivia?
Provide a succinct answer. 1.56. What is the ratio of the Amount (in current US$) of 1972 in South Asia to that in Bolivia?
Offer a terse response. 0.96. What is the ratio of the Amount (in current US$) in 1973 in South Asia to that in Bolivia?
Make the answer very short. 0.82. What is the ratio of the Amount (in current US$) of 1970 in South Asia to that in Brazil?
Your answer should be very brief. 0. What is the ratio of the Amount (in current US$) of 1971 in South Asia to that in Brazil?
Your response must be concise. 0.05. What is the ratio of the Amount (in current US$) of 1972 in South Asia to that in Brazil?
Keep it short and to the point. 0.07. What is the ratio of the Amount (in current US$) of 1973 in South Asia to that in Brazil?
Give a very brief answer. 0.11. What is the ratio of the Amount (in current US$) in 1970 in South Asia to that in Colombia?
Your answer should be compact. 0. What is the ratio of the Amount (in current US$) of 1971 in South Asia to that in Colombia?
Ensure brevity in your answer.  0.07. What is the ratio of the Amount (in current US$) of 1972 in South Asia to that in Colombia?
Offer a terse response. 0.23. What is the ratio of the Amount (in current US$) of 1973 in South Asia to that in Colombia?
Your response must be concise. 0.33. What is the ratio of the Amount (in current US$) in 1970 in Upper middle income to that in Bolivia?
Provide a short and direct response. 63.85. What is the ratio of the Amount (in current US$) of 1971 in Upper middle income to that in Bolivia?
Make the answer very short. 119.02. What is the ratio of the Amount (in current US$) of 1972 in Upper middle income to that in Bolivia?
Keep it short and to the point. 26.9. What is the ratio of the Amount (in current US$) of 1973 in Upper middle income to that in Bolivia?
Keep it short and to the point. 22.92. What is the ratio of the Amount (in current US$) in 1970 in Upper middle income to that in Brazil?
Give a very brief answer. 2.92. What is the ratio of the Amount (in current US$) of 1971 in Upper middle income to that in Brazil?
Your answer should be very brief. 3.54. What is the ratio of the Amount (in current US$) in 1972 in Upper middle income to that in Brazil?
Provide a short and direct response. 1.87. What is the ratio of the Amount (in current US$) in 1973 in Upper middle income to that in Brazil?
Make the answer very short. 3.18. What is the ratio of the Amount (in current US$) of 1970 in Upper middle income to that in Colombia?
Your answer should be compact. 6.14. What is the ratio of the Amount (in current US$) in 1971 in Upper middle income to that in Colombia?
Offer a terse response. 5.48. What is the ratio of the Amount (in current US$) in 1972 in Upper middle income to that in Colombia?
Keep it short and to the point. 6.29. What is the ratio of the Amount (in current US$) of 1973 in Upper middle income to that in Colombia?
Offer a terse response. 9.29. What is the ratio of the Amount (in current US$) of 1970 in Bolivia to that in Brazil?
Your answer should be compact. 0.05. What is the ratio of the Amount (in current US$) of 1971 in Bolivia to that in Brazil?
Ensure brevity in your answer.  0.03. What is the ratio of the Amount (in current US$) in 1972 in Bolivia to that in Brazil?
Your response must be concise. 0.07. What is the ratio of the Amount (in current US$) of 1973 in Bolivia to that in Brazil?
Provide a succinct answer. 0.14. What is the ratio of the Amount (in current US$) in 1970 in Bolivia to that in Colombia?
Your response must be concise. 0.1. What is the ratio of the Amount (in current US$) in 1971 in Bolivia to that in Colombia?
Provide a short and direct response. 0.05. What is the ratio of the Amount (in current US$) of 1972 in Bolivia to that in Colombia?
Provide a short and direct response. 0.23. What is the ratio of the Amount (in current US$) of 1973 in Bolivia to that in Colombia?
Your answer should be compact. 0.41. What is the ratio of the Amount (in current US$) in 1970 in Brazil to that in Colombia?
Give a very brief answer. 2.1. What is the ratio of the Amount (in current US$) in 1971 in Brazil to that in Colombia?
Offer a very short reply. 1.55. What is the ratio of the Amount (in current US$) in 1972 in Brazil to that in Colombia?
Your answer should be compact. 3.37. What is the ratio of the Amount (in current US$) of 1973 in Brazil to that in Colombia?
Provide a succinct answer. 2.93. What is the difference between the highest and the second highest Amount (in current US$) of 1970?
Offer a very short reply. 3.06e+07. What is the difference between the highest and the second highest Amount (in current US$) of 1971?
Offer a terse response. 2.74e+07. What is the difference between the highest and the second highest Amount (in current US$) of 1972?
Make the answer very short. 3.08e+07. What is the difference between the highest and the second highest Amount (in current US$) in 1973?
Offer a terse response. 6.06e+07. What is the difference between the highest and the lowest Amount (in current US$) of 1970?
Your response must be concise. 1.75e+08. What is the difference between the highest and the lowest Amount (in current US$) in 1971?
Ensure brevity in your answer.  1.52e+08. What is the difference between the highest and the lowest Amount (in current US$) of 1972?
Provide a succinct answer. 1.21e+08. What is the difference between the highest and the lowest Amount (in current US$) of 1973?
Offer a terse response. 2.01e+08. 